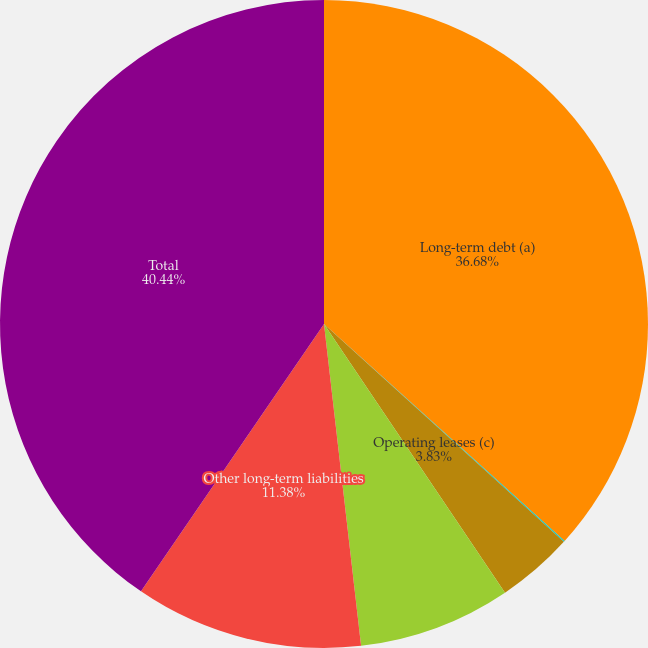<chart> <loc_0><loc_0><loc_500><loc_500><pie_chart><fcel>Long-term debt (a)<fcel>Capital leases (b)<fcel>Operating leases (c)<fcel>Purchase obligations (d)<fcel>Other long-term liabilities<fcel>Total<nl><fcel>36.68%<fcel>0.06%<fcel>3.83%<fcel>7.61%<fcel>11.38%<fcel>40.45%<nl></chart> 